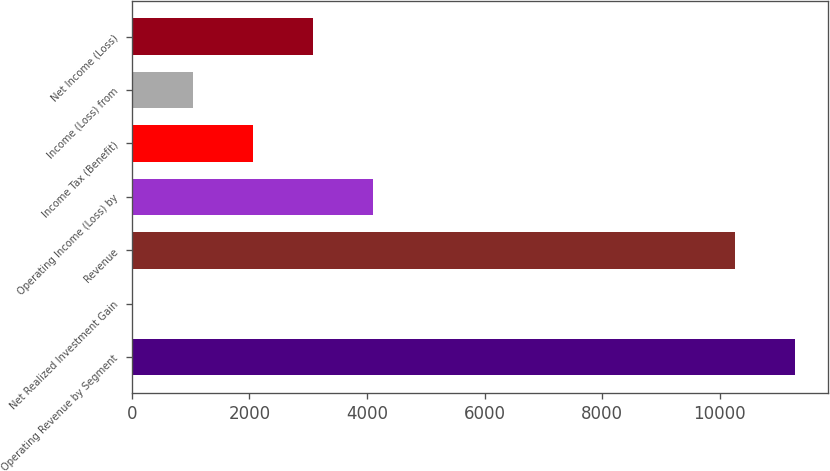Convert chart. <chart><loc_0><loc_0><loc_500><loc_500><bar_chart><fcel>Operating Revenue by Segment<fcel>Net Realized Investment Gain<fcel>Revenue<fcel>Operating Income (Loss) by<fcel>Income Tax (Benefit)<fcel>Income (Loss) from<fcel>Net Income (Loss)<nl><fcel>11285.2<fcel>6.7<fcel>10259.3<fcel>4110.42<fcel>2058.56<fcel>1032.63<fcel>3084.49<nl></chart> 